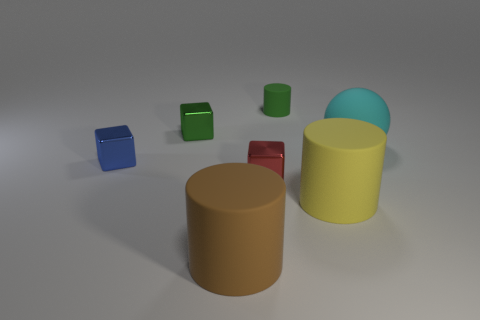Are there the same number of red blocks that are in front of the red metallic cube and green cubes?
Give a very brief answer. No. Are the object on the right side of the big yellow rubber cylinder and the big cylinder left of the red object made of the same material?
Offer a terse response. Yes. There is a green object in front of the small object to the right of the tiny red metal block; what is its shape?
Your response must be concise. Cube. There is a small cylinder that is the same material as the large brown object; what color is it?
Offer a terse response. Green. What is the shape of the cyan thing that is the same size as the brown cylinder?
Give a very brief answer. Sphere. What is the size of the brown object?
Provide a short and direct response. Large. There is a green thing that is left of the green matte object; does it have the same size as the cylinder behind the big cyan thing?
Provide a succinct answer. Yes. There is a metal object on the right side of the green thing to the left of the small green cylinder; what color is it?
Give a very brief answer. Red. There is a green block that is the same size as the green rubber cylinder; what is its material?
Offer a very short reply. Metal. How many rubber objects are either green balls or green cubes?
Give a very brief answer. 0. 